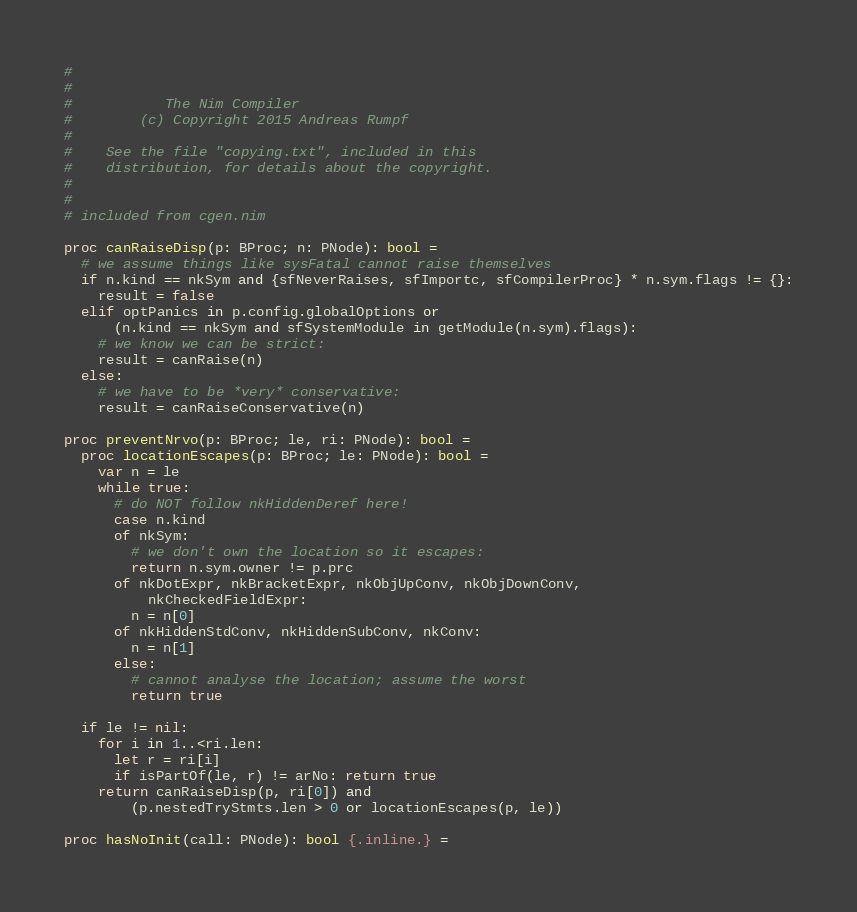Convert code to text. <code><loc_0><loc_0><loc_500><loc_500><_Nim_>#
#
#           The Nim Compiler
#        (c) Copyright 2015 Andreas Rumpf
#
#    See the file "copying.txt", included in this
#    distribution, for details about the copyright.
#
#
# included from cgen.nim

proc canRaiseDisp(p: BProc; n: PNode): bool =
  # we assume things like sysFatal cannot raise themselves
  if n.kind == nkSym and {sfNeverRaises, sfImportc, sfCompilerProc} * n.sym.flags != {}:
    result = false
  elif optPanics in p.config.globalOptions or
      (n.kind == nkSym and sfSystemModule in getModule(n.sym).flags):
    # we know we can be strict:
    result = canRaise(n)
  else:
    # we have to be *very* conservative:
    result = canRaiseConservative(n)

proc preventNrvo(p: BProc; le, ri: PNode): bool =
  proc locationEscapes(p: BProc; le: PNode): bool =
    var n = le
    while true:
      # do NOT follow nkHiddenDeref here!
      case n.kind
      of nkSym:
        # we don't own the location so it escapes:
        return n.sym.owner != p.prc
      of nkDotExpr, nkBracketExpr, nkObjUpConv, nkObjDownConv,
          nkCheckedFieldExpr:
        n = n[0]
      of nkHiddenStdConv, nkHiddenSubConv, nkConv:
        n = n[1]
      else:
        # cannot analyse the location; assume the worst
        return true

  if le != nil:
    for i in 1..<ri.len:
      let r = ri[i]
      if isPartOf(le, r) != arNo: return true
    return canRaiseDisp(p, ri[0]) and
        (p.nestedTryStmts.len > 0 or locationEscapes(p, le))

proc hasNoInit(call: PNode): bool {.inline.} =</code> 